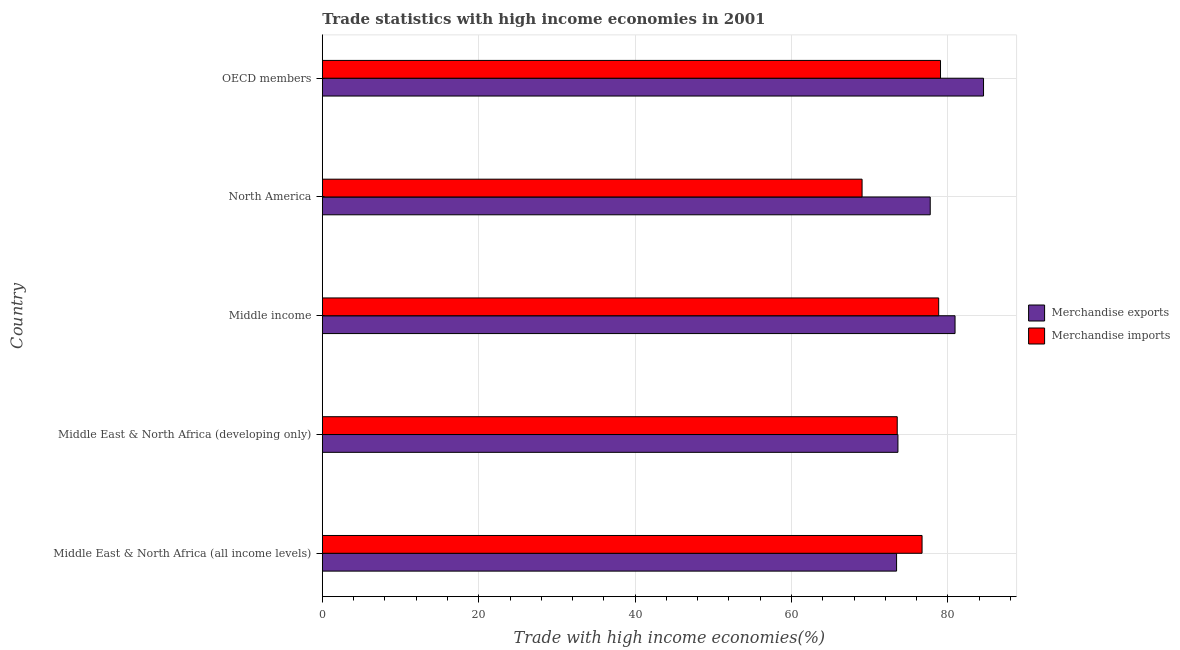How many different coloured bars are there?
Ensure brevity in your answer.  2. How many groups of bars are there?
Keep it short and to the point. 5. Are the number of bars per tick equal to the number of legend labels?
Make the answer very short. Yes. Are the number of bars on each tick of the Y-axis equal?
Your answer should be very brief. Yes. How many bars are there on the 3rd tick from the top?
Your response must be concise. 2. How many bars are there on the 1st tick from the bottom?
Give a very brief answer. 2. What is the label of the 5th group of bars from the top?
Your answer should be very brief. Middle East & North Africa (all income levels). In how many cases, is the number of bars for a given country not equal to the number of legend labels?
Keep it short and to the point. 0. What is the merchandise imports in OECD members?
Keep it short and to the point. 79.05. Across all countries, what is the maximum merchandise imports?
Ensure brevity in your answer.  79.05. Across all countries, what is the minimum merchandise exports?
Ensure brevity in your answer.  73.43. In which country was the merchandise exports maximum?
Provide a short and direct response. OECD members. In which country was the merchandise imports minimum?
Provide a short and direct response. North America. What is the total merchandise imports in the graph?
Keep it short and to the point. 377.08. What is the difference between the merchandise imports in Middle East & North Africa (all income levels) and that in OECD members?
Your answer should be compact. -2.36. What is the difference between the merchandise exports in Middle income and the merchandise imports in Middle East & North Africa (all income levels)?
Your answer should be compact. 4.22. What is the average merchandise imports per country?
Make the answer very short. 75.42. What is the difference between the merchandise imports and merchandise exports in Middle income?
Provide a succinct answer. -2.09. What is the ratio of the merchandise exports in North America to that in OECD members?
Keep it short and to the point. 0.92. What is the difference between the highest and the second highest merchandise imports?
Your answer should be compact. 0.23. What is the difference between the highest and the lowest merchandise exports?
Make the answer very short. 11.12. Is the sum of the merchandise exports in Middle East & North Africa (all income levels) and North America greater than the maximum merchandise imports across all countries?
Your response must be concise. Yes. What does the 1st bar from the bottom in Middle East & North Africa (developing only) represents?
Your answer should be compact. Merchandise exports. How many bars are there?
Ensure brevity in your answer.  10. Are all the bars in the graph horizontal?
Give a very brief answer. Yes. Are the values on the major ticks of X-axis written in scientific E-notation?
Your response must be concise. No. Does the graph contain any zero values?
Your answer should be very brief. No. Does the graph contain grids?
Your answer should be very brief. Yes. Where does the legend appear in the graph?
Give a very brief answer. Center right. How are the legend labels stacked?
Provide a short and direct response. Vertical. What is the title of the graph?
Offer a very short reply. Trade statistics with high income economies in 2001. What is the label or title of the X-axis?
Make the answer very short. Trade with high income economies(%). What is the Trade with high income economies(%) of Merchandise exports in Middle East & North Africa (all income levels)?
Provide a short and direct response. 73.43. What is the Trade with high income economies(%) in Merchandise imports in Middle East & North Africa (all income levels)?
Keep it short and to the point. 76.69. What is the Trade with high income economies(%) in Merchandise exports in Middle East & North Africa (developing only)?
Give a very brief answer. 73.6. What is the Trade with high income economies(%) in Merchandise imports in Middle East & North Africa (developing only)?
Your answer should be compact. 73.51. What is the Trade with high income economies(%) in Merchandise exports in Middle income?
Give a very brief answer. 80.91. What is the Trade with high income economies(%) of Merchandise imports in Middle income?
Provide a succinct answer. 78.81. What is the Trade with high income economies(%) of Merchandise exports in North America?
Ensure brevity in your answer.  77.73. What is the Trade with high income economies(%) in Merchandise imports in North America?
Ensure brevity in your answer.  69.02. What is the Trade with high income economies(%) in Merchandise exports in OECD members?
Your answer should be compact. 84.55. What is the Trade with high income economies(%) of Merchandise imports in OECD members?
Give a very brief answer. 79.05. Across all countries, what is the maximum Trade with high income economies(%) in Merchandise exports?
Your response must be concise. 84.55. Across all countries, what is the maximum Trade with high income economies(%) in Merchandise imports?
Offer a very short reply. 79.05. Across all countries, what is the minimum Trade with high income economies(%) in Merchandise exports?
Provide a short and direct response. 73.43. Across all countries, what is the minimum Trade with high income economies(%) in Merchandise imports?
Your response must be concise. 69.02. What is the total Trade with high income economies(%) of Merchandise exports in the graph?
Offer a very short reply. 390.22. What is the total Trade with high income economies(%) in Merchandise imports in the graph?
Offer a very short reply. 377.08. What is the difference between the Trade with high income economies(%) in Merchandise exports in Middle East & North Africa (all income levels) and that in Middle East & North Africa (developing only)?
Your answer should be very brief. -0.18. What is the difference between the Trade with high income economies(%) of Merchandise imports in Middle East & North Africa (all income levels) and that in Middle East & North Africa (developing only)?
Your answer should be very brief. 3.17. What is the difference between the Trade with high income economies(%) in Merchandise exports in Middle East & North Africa (all income levels) and that in Middle income?
Your answer should be very brief. -7.48. What is the difference between the Trade with high income economies(%) of Merchandise imports in Middle East & North Africa (all income levels) and that in Middle income?
Your response must be concise. -2.13. What is the difference between the Trade with high income economies(%) of Merchandise exports in Middle East & North Africa (all income levels) and that in North America?
Your answer should be compact. -4.3. What is the difference between the Trade with high income economies(%) of Merchandise imports in Middle East & North Africa (all income levels) and that in North America?
Give a very brief answer. 7.67. What is the difference between the Trade with high income economies(%) in Merchandise exports in Middle East & North Africa (all income levels) and that in OECD members?
Give a very brief answer. -11.12. What is the difference between the Trade with high income economies(%) of Merchandise imports in Middle East & North Africa (all income levels) and that in OECD members?
Provide a short and direct response. -2.36. What is the difference between the Trade with high income economies(%) in Merchandise exports in Middle East & North Africa (developing only) and that in Middle income?
Give a very brief answer. -7.3. What is the difference between the Trade with high income economies(%) in Merchandise imports in Middle East & North Africa (developing only) and that in Middle income?
Give a very brief answer. -5.3. What is the difference between the Trade with high income economies(%) of Merchandise exports in Middle East & North Africa (developing only) and that in North America?
Make the answer very short. -4.13. What is the difference between the Trade with high income economies(%) of Merchandise imports in Middle East & North Africa (developing only) and that in North America?
Ensure brevity in your answer.  4.5. What is the difference between the Trade with high income economies(%) in Merchandise exports in Middle East & North Africa (developing only) and that in OECD members?
Keep it short and to the point. -10.94. What is the difference between the Trade with high income economies(%) in Merchandise imports in Middle East & North Africa (developing only) and that in OECD members?
Your answer should be compact. -5.53. What is the difference between the Trade with high income economies(%) in Merchandise exports in Middle income and that in North America?
Provide a succinct answer. 3.17. What is the difference between the Trade with high income economies(%) in Merchandise imports in Middle income and that in North America?
Provide a short and direct response. 9.8. What is the difference between the Trade with high income economies(%) of Merchandise exports in Middle income and that in OECD members?
Keep it short and to the point. -3.64. What is the difference between the Trade with high income economies(%) in Merchandise imports in Middle income and that in OECD members?
Offer a terse response. -0.23. What is the difference between the Trade with high income economies(%) of Merchandise exports in North America and that in OECD members?
Ensure brevity in your answer.  -6.82. What is the difference between the Trade with high income economies(%) in Merchandise imports in North America and that in OECD members?
Your response must be concise. -10.03. What is the difference between the Trade with high income economies(%) in Merchandise exports in Middle East & North Africa (all income levels) and the Trade with high income economies(%) in Merchandise imports in Middle East & North Africa (developing only)?
Make the answer very short. -0.09. What is the difference between the Trade with high income economies(%) in Merchandise exports in Middle East & North Africa (all income levels) and the Trade with high income economies(%) in Merchandise imports in Middle income?
Your answer should be very brief. -5.39. What is the difference between the Trade with high income economies(%) of Merchandise exports in Middle East & North Africa (all income levels) and the Trade with high income economies(%) of Merchandise imports in North America?
Provide a succinct answer. 4.41. What is the difference between the Trade with high income economies(%) in Merchandise exports in Middle East & North Africa (all income levels) and the Trade with high income economies(%) in Merchandise imports in OECD members?
Give a very brief answer. -5.62. What is the difference between the Trade with high income economies(%) of Merchandise exports in Middle East & North Africa (developing only) and the Trade with high income economies(%) of Merchandise imports in Middle income?
Make the answer very short. -5.21. What is the difference between the Trade with high income economies(%) in Merchandise exports in Middle East & North Africa (developing only) and the Trade with high income economies(%) in Merchandise imports in North America?
Offer a very short reply. 4.59. What is the difference between the Trade with high income economies(%) in Merchandise exports in Middle East & North Africa (developing only) and the Trade with high income economies(%) in Merchandise imports in OECD members?
Make the answer very short. -5.44. What is the difference between the Trade with high income economies(%) of Merchandise exports in Middle income and the Trade with high income economies(%) of Merchandise imports in North America?
Offer a terse response. 11.89. What is the difference between the Trade with high income economies(%) of Merchandise exports in Middle income and the Trade with high income economies(%) of Merchandise imports in OECD members?
Offer a very short reply. 1.86. What is the difference between the Trade with high income economies(%) in Merchandise exports in North America and the Trade with high income economies(%) in Merchandise imports in OECD members?
Ensure brevity in your answer.  -1.32. What is the average Trade with high income economies(%) in Merchandise exports per country?
Provide a short and direct response. 78.04. What is the average Trade with high income economies(%) of Merchandise imports per country?
Provide a succinct answer. 75.42. What is the difference between the Trade with high income economies(%) in Merchandise exports and Trade with high income economies(%) in Merchandise imports in Middle East & North Africa (all income levels)?
Provide a short and direct response. -3.26. What is the difference between the Trade with high income economies(%) of Merchandise exports and Trade with high income economies(%) of Merchandise imports in Middle East & North Africa (developing only)?
Your answer should be compact. 0.09. What is the difference between the Trade with high income economies(%) in Merchandise exports and Trade with high income economies(%) in Merchandise imports in Middle income?
Give a very brief answer. 2.09. What is the difference between the Trade with high income economies(%) of Merchandise exports and Trade with high income economies(%) of Merchandise imports in North America?
Keep it short and to the point. 8.71. What is the difference between the Trade with high income economies(%) in Merchandise exports and Trade with high income economies(%) in Merchandise imports in OECD members?
Your response must be concise. 5.5. What is the ratio of the Trade with high income economies(%) of Merchandise exports in Middle East & North Africa (all income levels) to that in Middle East & North Africa (developing only)?
Your response must be concise. 1. What is the ratio of the Trade with high income economies(%) of Merchandise imports in Middle East & North Africa (all income levels) to that in Middle East & North Africa (developing only)?
Provide a succinct answer. 1.04. What is the ratio of the Trade with high income economies(%) of Merchandise exports in Middle East & North Africa (all income levels) to that in Middle income?
Your response must be concise. 0.91. What is the ratio of the Trade with high income economies(%) in Merchandise exports in Middle East & North Africa (all income levels) to that in North America?
Make the answer very short. 0.94. What is the ratio of the Trade with high income economies(%) in Merchandise exports in Middle East & North Africa (all income levels) to that in OECD members?
Offer a very short reply. 0.87. What is the ratio of the Trade with high income economies(%) in Merchandise imports in Middle East & North Africa (all income levels) to that in OECD members?
Your response must be concise. 0.97. What is the ratio of the Trade with high income economies(%) of Merchandise exports in Middle East & North Africa (developing only) to that in Middle income?
Your answer should be very brief. 0.91. What is the ratio of the Trade with high income economies(%) in Merchandise imports in Middle East & North Africa (developing only) to that in Middle income?
Keep it short and to the point. 0.93. What is the ratio of the Trade with high income economies(%) in Merchandise exports in Middle East & North Africa (developing only) to that in North America?
Your answer should be very brief. 0.95. What is the ratio of the Trade with high income economies(%) of Merchandise imports in Middle East & North Africa (developing only) to that in North America?
Your answer should be very brief. 1.07. What is the ratio of the Trade with high income economies(%) in Merchandise exports in Middle East & North Africa (developing only) to that in OECD members?
Provide a succinct answer. 0.87. What is the ratio of the Trade with high income economies(%) of Merchandise exports in Middle income to that in North America?
Your response must be concise. 1.04. What is the ratio of the Trade with high income economies(%) in Merchandise imports in Middle income to that in North America?
Give a very brief answer. 1.14. What is the ratio of the Trade with high income economies(%) in Merchandise exports in Middle income to that in OECD members?
Your response must be concise. 0.96. What is the ratio of the Trade with high income economies(%) of Merchandise imports in Middle income to that in OECD members?
Provide a succinct answer. 1. What is the ratio of the Trade with high income economies(%) in Merchandise exports in North America to that in OECD members?
Provide a short and direct response. 0.92. What is the ratio of the Trade with high income economies(%) in Merchandise imports in North America to that in OECD members?
Offer a very short reply. 0.87. What is the difference between the highest and the second highest Trade with high income economies(%) in Merchandise exports?
Ensure brevity in your answer.  3.64. What is the difference between the highest and the second highest Trade with high income economies(%) of Merchandise imports?
Offer a terse response. 0.23. What is the difference between the highest and the lowest Trade with high income economies(%) in Merchandise exports?
Offer a very short reply. 11.12. What is the difference between the highest and the lowest Trade with high income economies(%) in Merchandise imports?
Keep it short and to the point. 10.03. 